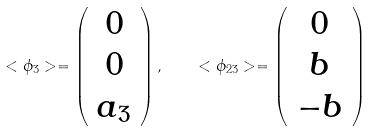Convert formula to latex. <formula><loc_0><loc_0><loc_500><loc_500>< \phi _ { 3 } > = \left ( \begin{array} { c } 0 \\ 0 \\ a _ { 3 } \end{array} \right ) , \quad < \phi _ { 2 3 } > = \left ( \begin{array} { c } 0 \\ b \\ - b \end{array} \right )</formula> 